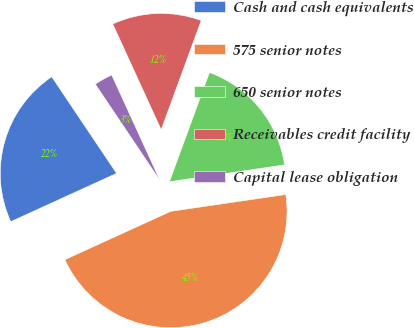<chart> <loc_0><loc_0><loc_500><loc_500><pie_chart><fcel>Cash and cash equivalents<fcel>575 senior notes<fcel>650 senior notes<fcel>Receivables credit facility<fcel>Capital lease obligation<nl><fcel>22.41%<fcel>45.5%<fcel>17.1%<fcel>12.43%<fcel>2.57%<nl></chart> 